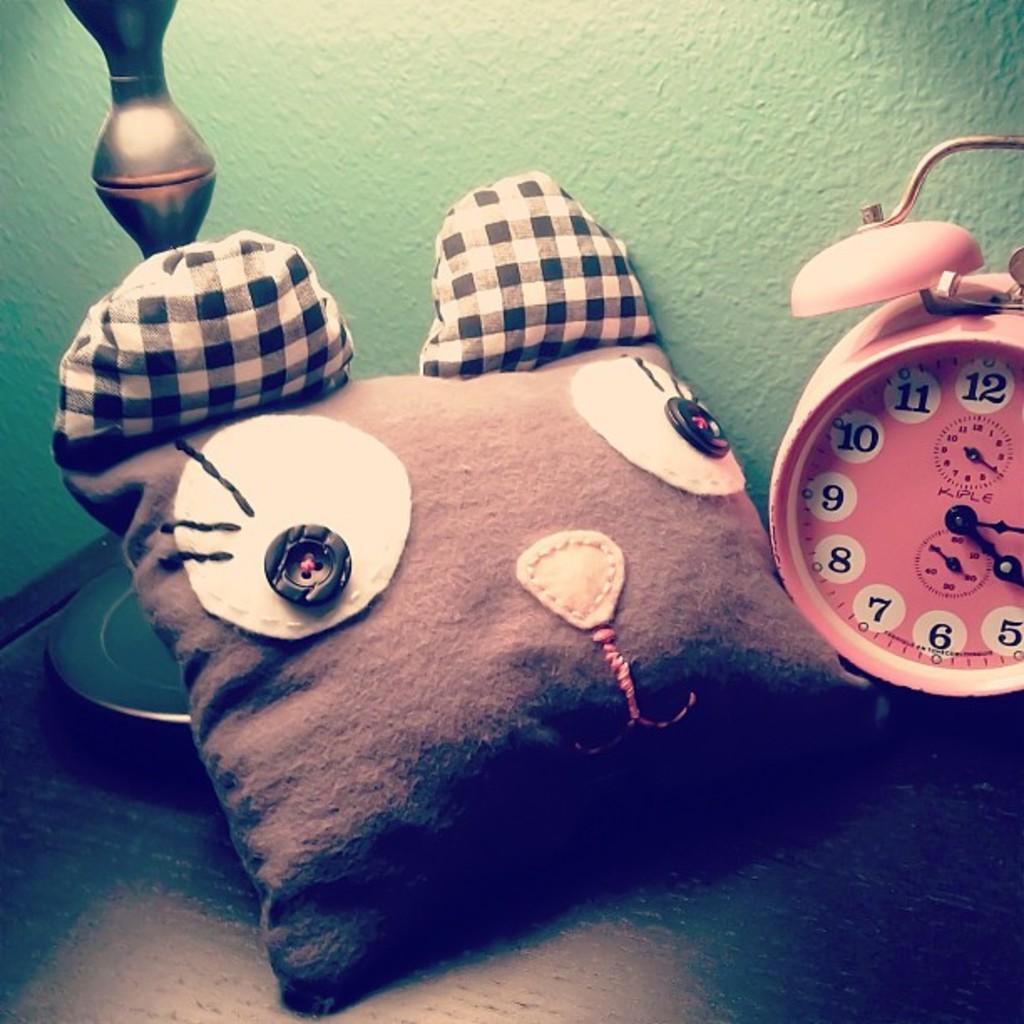<image>
Describe the image concisely. Animal shaped pillow next to a red Kiple clock. 